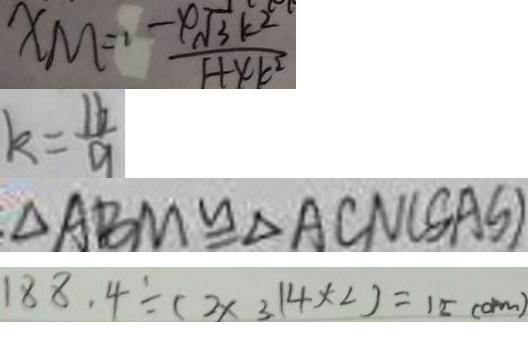Convert formula to latex. <formula><loc_0><loc_0><loc_500><loc_500>X M = \frac { - 4 \sqrt { 3 } k ^ { 2 } } { 1 + 4 k ^ { 2 } } 
 k = \frac { 1 6 } { 9 } 
 \Delta A B M \cong \Delta A C N ( S A S ) 
 1 8 8 . 4 \div ( 2 \times 3 . 1 4 \times 2 ) = 1 5 ( c m )</formula> 